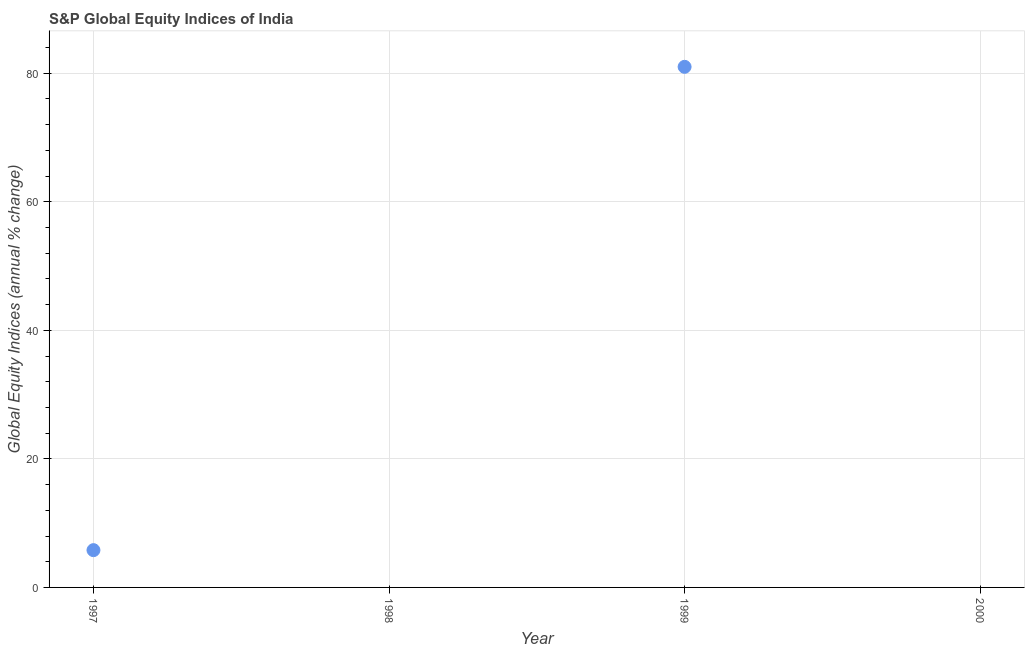What is the s&p global equity indices in 2000?
Give a very brief answer. 0. Across all years, what is the minimum s&p global equity indices?
Provide a succinct answer. 0. In which year was the s&p global equity indices maximum?
Your answer should be compact. 1999. What is the sum of the s&p global equity indices?
Ensure brevity in your answer.  86.8. What is the difference between the s&p global equity indices in 1997 and 1999?
Provide a succinct answer. -75.2. What is the average s&p global equity indices per year?
Keep it short and to the point. 21.7. What is the median s&p global equity indices?
Your response must be concise. 2.9. In how many years, is the s&p global equity indices greater than 76 %?
Offer a terse response. 1. What is the difference between the highest and the lowest s&p global equity indices?
Make the answer very short. 81. In how many years, is the s&p global equity indices greater than the average s&p global equity indices taken over all years?
Your answer should be very brief. 1. How many dotlines are there?
Offer a terse response. 1. What is the difference between two consecutive major ticks on the Y-axis?
Give a very brief answer. 20. Are the values on the major ticks of Y-axis written in scientific E-notation?
Your answer should be very brief. No. Does the graph contain any zero values?
Ensure brevity in your answer.  Yes. Does the graph contain grids?
Your response must be concise. Yes. What is the title of the graph?
Make the answer very short. S&P Global Equity Indices of India. What is the label or title of the Y-axis?
Make the answer very short. Global Equity Indices (annual % change). What is the Global Equity Indices (annual % change) in 1997?
Provide a succinct answer. 5.8. What is the Global Equity Indices (annual % change) in 1998?
Your answer should be very brief. 0. What is the Global Equity Indices (annual % change) in 2000?
Keep it short and to the point. 0. What is the difference between the Global Equity Indices (annual % change) in 1997 and 1999?
Make the answer very short. -75.2. What is the ratio of the Global Equity Indices (annual % change) in 1997 to that in 1999?
Provide a succinct answer. 0.07. 